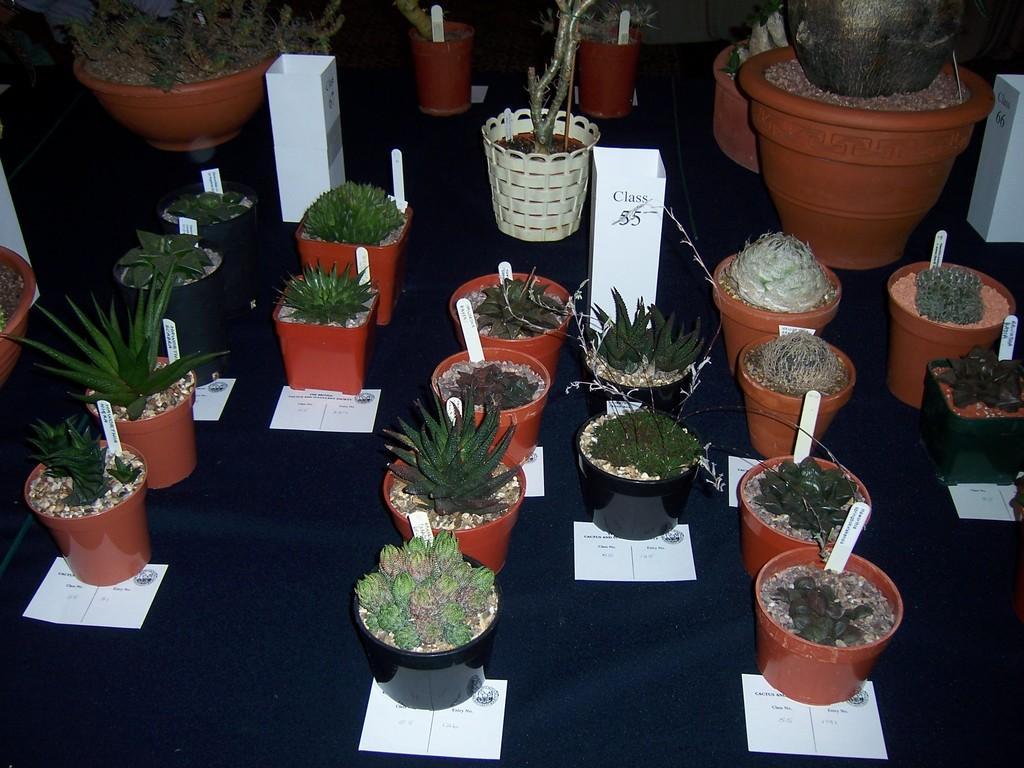Describe this image in one or two sentences. In the foreground of this image, there are many potted plants are on a black colored table. 